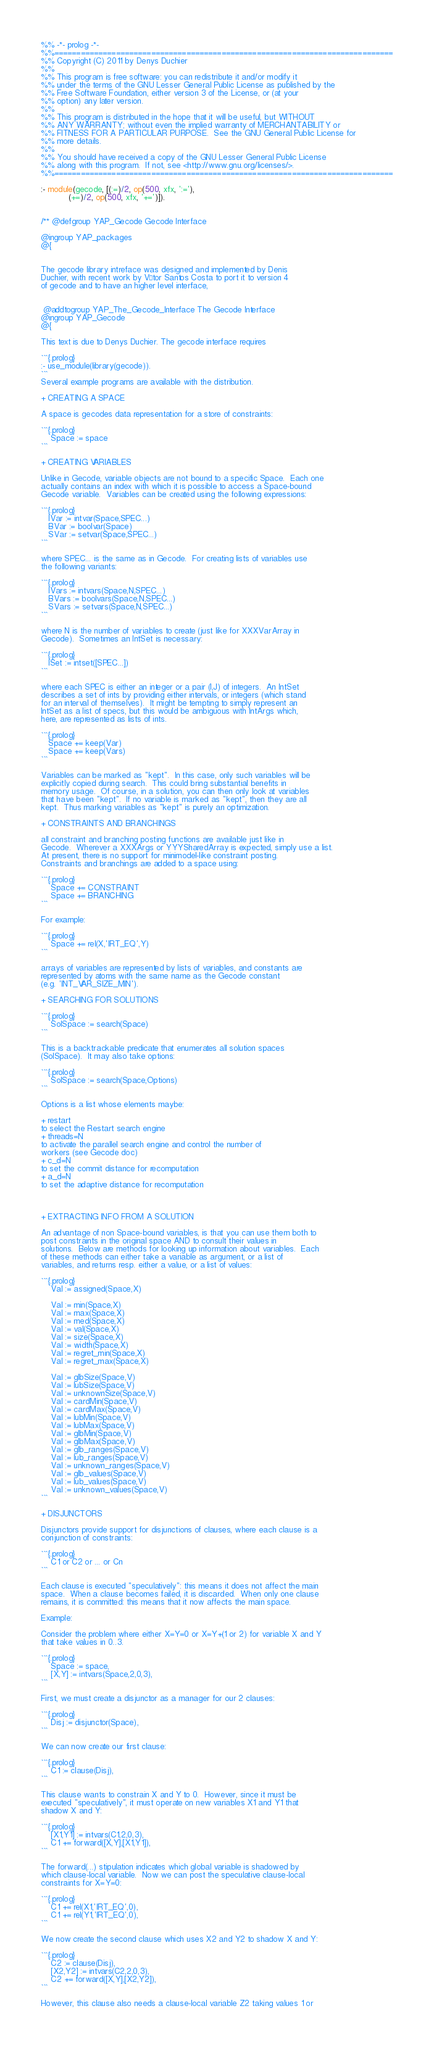<code> <loc_0><loc_0><loc_500><loc_500><_Prolog_>%% -*- prolog -*-
%%=============================================================================
%% Copyright (C) 2011 by Denys Duchier
%%
%% This program is free software: you can redistribute it and/or modify it
%% under the terms of the GNU Lesser General Public License as published by the
%% Free Software Foundation, either version 3 of the License, or (at your
%% option) any later version.
%%
%% This program is distributed in the hope that it will be useful, but WITHOUT
%% ANY WARRANTY; without even the implied warranty of MERCHANTABILITY or
%% FITNESS FOR A PARTICULAR PURPOSE.  See the GNU General Public License for
%% more details.
%%
%% You should have received a copy of the GNU Lesser General Public License
%% along with this program.  If not, see <http://www.gnu.org/licenses/>.
%%=============================================================================

:- module(gecode, [(:=)/2, op(500, xfx, ':='),
		   (+=)/2, op(500, xfx, '+=')]).


/** @defgroup YAP_Gecode Gecode Interface

@ingroup YAP_packages
@{


The gecode library intreface was designed and implemented by Denis
Duchier, with recent work by Vítor Santos Costa to port it to version 4
of gecode and to have an higher level interface,


 @addtogroup YAP_The_Gecode_Interface The Gecode Interface
@ingroup YAP_Gecode
@{

This text is due to Denys Duchier. The gecode interface requires

```{.prolog}
:- use_module(library(gecode)).
```
Several example programs are available with the distribution.

+ CREATING A SPACE

A space is gecodes data representation for a store of constraints:

```{.prolog}
    Space := space
```

+ CREATING VARIABLES

Unlike in Gecode, variable objects are not bound to a specific Space.  Each one
actually contains an index with which it is possible to access a Space-bound
Gecode variable.  Variables can be created using the following expressions:

```{.prolog}
   IVar := intvar(Space,SPEC...)
   BVar := boolvar(Space)
   SVar := setvar(Space,SPEC...)
```

where SPEC... is the same as in Gecode.  For creating lists of variables use
the following variants:

```{.prolog}
   IVars := intvars(Space,N,SPEC...)
   BVars := boolvars(Space,N,SPEC...)
   SVars := setvars(Space,N,SPEC...)
```

where N is the number of variables to create (just like for XXXVarArray in
Gecode).  Sometimes an IntSet is necessary:

```{.prolog}
   ISet := intset([SPEC...])
```

where each SPEC is either an integer or a pair (I,J) of integers.  An IntSet
describes a set of ints by providing either intervals, or integers (which stand
for an interval of themselves).  It might be tempting to simply represent an
IntSet as a list of specs, but this would be ambiguous with IntArgs which,
here, are represented as lists of ints.

```{.prolog}
   Space += keep(Var)
   Space += keep(Vars)
```

Variables can be marked as "kept".  In this case, only such variables will be
explicitly copied during search.  This could bring substantial benefits in
memory usage.  Of course, in a solution, you can then only look at variables
that have been "kept".  If no variable is marked as "kept", then they are all
kept.  Thus marking variables as "kept" is purely an optimization.

+ CONSTRAINTS AND BRANCHINGS

all constraint and branching posting functions are available just like in
Gecode.  Wherever a XXXArgs or YYYSharedArray is expected, simply use a list.
At present, there is no support for minimodel-like constraint posting.
Constraints and branchings are added to a space using:

```{.prolog}
    Space += CONSTRAINT
    Space += BRANCHING
```

For example:

```{.prolog}
    Space += rel(X,'IRT_EQ',Y)
```

arrays of variables are represented by lists of variables, and constants are
represented by atoms with the same name as the Gecode constant
(e.g. 'INT_VAR_SIZE_MIN').

+ SEARCHING FOR SOLUTIONS

```{.prolog}
    SolSpace := search(Space)
```

This is a backtrackable predicate that enumerates all solution spaces
(SolSpace).  It may also take options:

```{.prolog}
    SolSpace := search(Space,Options)
```

Options is a list whose elements maybe:

+ restart
to select the Restart search engine
+ threads=N
to activate the parallel search engine and control the number of
workers (see Gecode doc)
+ c_d=N
to set the commit distance for recomputation
+ a_d=N
to set the adaptive distance for recomputation



+ EXTRACTING INFO FROM A SOLUTION

An advantage of non Space-bound variables, is that you can use them both to
post constraints in the original space AND to consult their values in
solutions.  Below are methods for looking up information about variables.  Each
of these methods can either take a variable as argument, or a list of
variables, and returns resp. either a value, or a list of values:

```{.prolog}
    Val := assigned(Space,X)

    Val := min(Space,X)
    Val := max(Space,X)
    Val := med(Space,X)
    Val := val(Space,X)
    Val := size(Space,X)
    Val := width(Space,X)
    Val := regret_min(Space,X)
    Val := regret_max(Space,X)

    Val := glbSize(Space,V)
    Val := lubSize(Space,V)
    Val := unknownSize(Space,V)
    Val := cardMin(Space,V)
    Val := cardMax(Space,V)
    Val := lubMin(Space,V)
    Val := lubMax(Space,V)
    Val := glbMin(Space,V)
    Val := glbMax(Space,V)
    Val := glb_ranges(Space,V)
    Val := lub_ranges(Space,V)
    Val := unknown_ranges(Space,V)
    Val := glb_values(Space,V)
    Val := lub_values(Space,V)
    Val := unknown_values(Space,V)
```

+ DISJUNCTORS

Disjunctors provide support for disjunctions of clauses, where each clause is a
conjunction of constraints:

```{.prolog}
    C1 or C2 or ... or Cn
```

Each clause is executed "speculatively": this means it does not affect the main
space.  When a clause becomes failed, it is discarded.  When only one clause
remains, it is committed: this means that it now affects the main space.

Example:

Consider the problem where either X=Y=0 or X=Y+(1 or 2) for variable X and Y
that take values in 0..3.

```{.prolog}
    Space := space,
    [X,Y] := intvars(Space,2,0,3),
```

First, we must create a disjunctor as a manager for our 2 clauses:

```{.prolog}
    Disj := disjunctor(Space),
```

We can now create our first clause:

```{.prolog}
    C1 := clause(Disj),
```

This clause wants to constrain X and Y to 0.  However, since it must be
executed "speculatively", it must operate on new variables X1 and Y1 that
shadow X and Y:

```{.prolog}
    [X1,Y1] := intvars(C1,2,0,3),
    C1 += forward([X,Y],[X1,Y1]),
```

The forward(...) stipulation indicates which global variable is shadowed by
which clause-local variable.  Now we can post the speculative clause-local
constraints for X=Y=0:

```{.prolog}
    C1 += rel(X1,'IRT_EQ',0),
    C1 += rel(Y1,'IRT_EQ',0),
```

We now create the second clause which uses X2 and Y2 to shadow X and Y:

```{.prolog}
    C2 := clause(Disj),
    [X2,Y2] := intvars(C2,2,0,3),
    C2 += forward([X,Y],[X2,Y2]),
```

However, this clause also needs a clause-local variable Z2 taking values 1 or</code> 